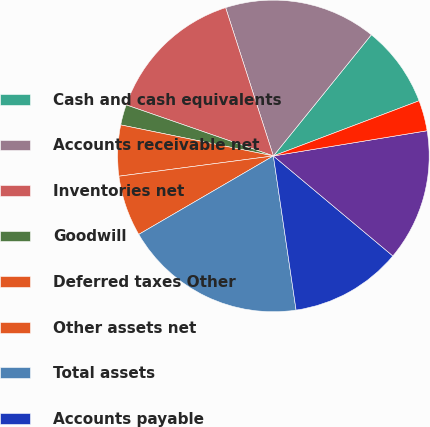Convert chart to OTSL. <chart><loc_0><loc_0><loc_500><loc_500><pie_chart><fcel>Cash and cash equivalents<fcel>Accounts receivable net<fcel>Inventories net<fcel>Goodwill<fcel>Deferred taxes Other<fcel>Other assets net<fcel>Total assets<fcel>Accounts payable<fcel>Accrued liabilities<fcel>Debt due within one year<nl><fcel>8.42%<fcel>15.78%<fcel>14.73%<fcel>2.12%<fcel>5.27%<fcel>6.32%<fcel>18.93%<fcel>11.58%<fcel>13.68%<fcel>3.17%<nl></chart> 